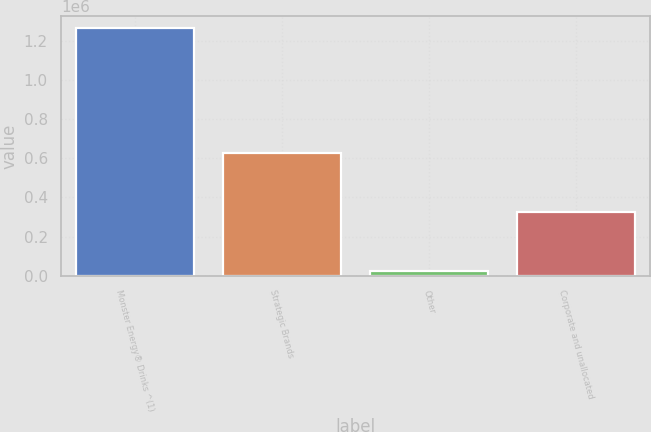Convert chart to OTSL. <chart><loc_0><loc_0><loc_500><loc_500><bar_chart><fcel>Monster Energy® Drinks ^(1)<fcel>Strategic Brands<fcel>Other<fcel>Corporate and unallocated<nl><fcel>1.26458e+06<fcel>626803<fcel>21605<fcel>324204<nl></chart> 